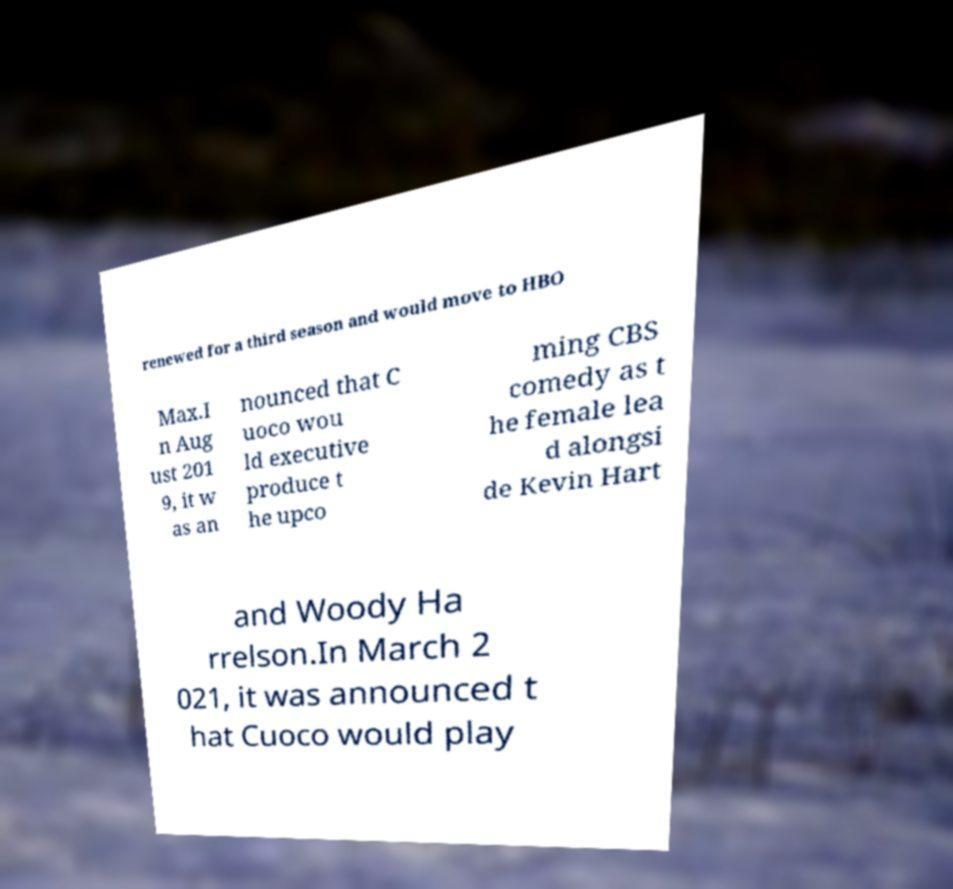Could you assist in decoding the text presented in this image and type it out clearly? renewed for a third season and would move to HBO Max.I n Aug ust 201 9, it w as an nounced that C uoco wou ld executive produce t he upco ming CBS comedy as t he female lea d alongsi de Kevin Hart and Woody Ha rrelson.In March 2 021, it was announced t hat Cuoco would play 